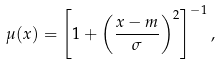Convert formula to latex. <formula><loc_0><loc_0><loc_500><loc_500>\mu ( x ) = \left [ 1 + \left ( \frac { x - m } { \sigma } \right ) ^ { 2 } \right ] ^ { - 1 } ,</formula> 